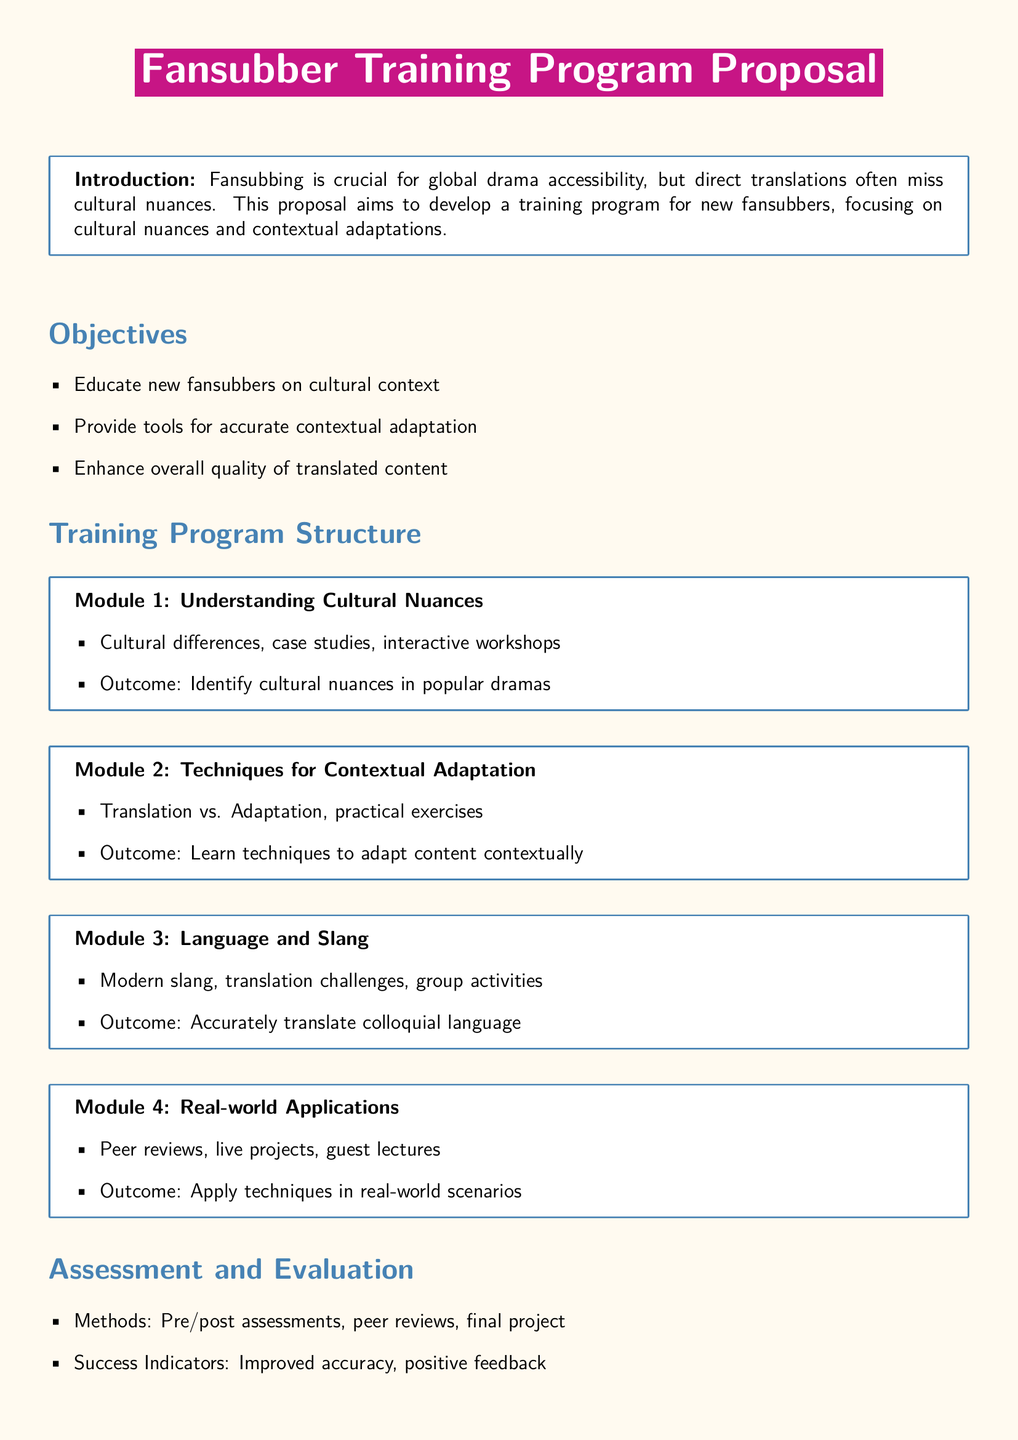What is the main focus of the proposal? The proposal aims to develop a training program for new fansubbers, focusing on cultural nuances and contextual adaptations.
Answer: cultural nuances and contextual adaptations How many modules are in the training program? The document lists four specific modules in the training program structure.
Answer: four What is the outcome of Module 1? The outcome of Module 1 is to identify cultural nuances in popular dramas.
Answer: Identify cultural nuances in popular dramas What type of activities does Module 3 include? Module 3 incorporates group activities related to modern slang and translation challenges.
Answer: group activities What assessment methods are mentioned in the document? The assessment methods include pre/post assessments, peer reviews, and a final project.
Answer: pre/post assessments, peer reviews, final project What is the ultimate goal of the proposed training program? The goal is to improve the quality of fansubbed content by equipping fansubbers with necessary skills.
Answer: improve the quality of fansubbed content What is the color of the title box? The title box is colored with the RGB value of 199,21,133.
Answer: RGB(199,21,133) Which module focuses on practical exercises? Module 2 emphasizes practical exercises in techniques for contextual adaptation.
Answer: Module 2 What will participants learn about in Module 4? Participants will apply techniques in real-world scenarios through peer reviews and live projects.
Answer: apply techniques in real-world scenarios 